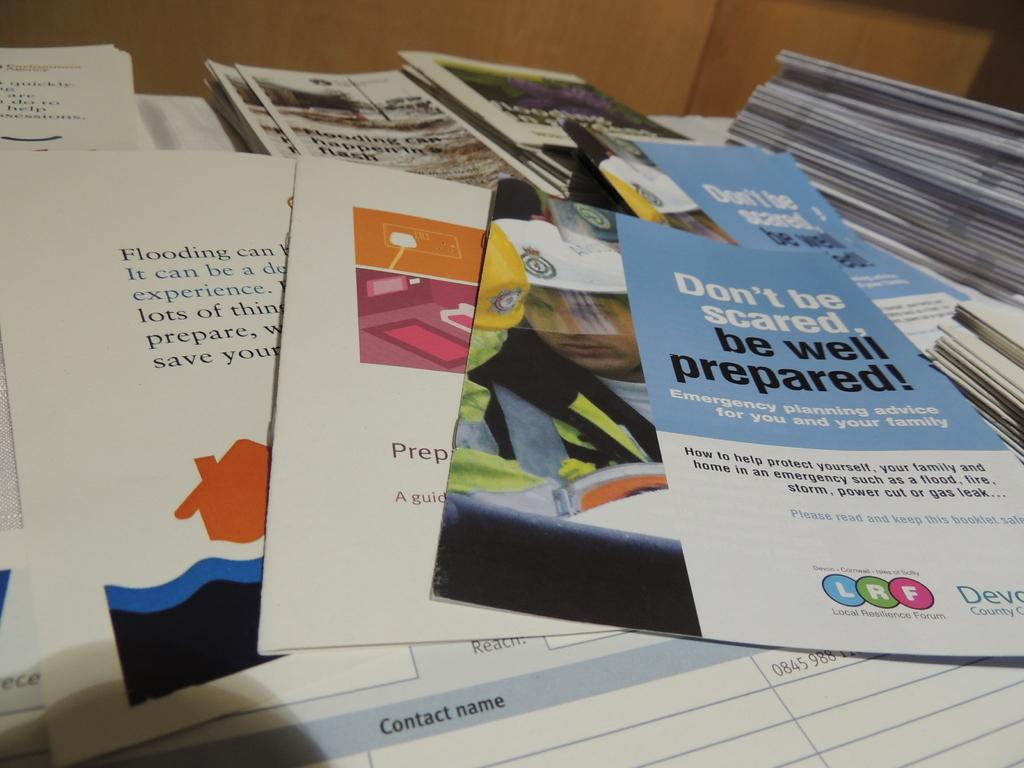Provide a one-sentence caption for the provided image. The brochure's title is "Don't be scared, be well prepared!". 